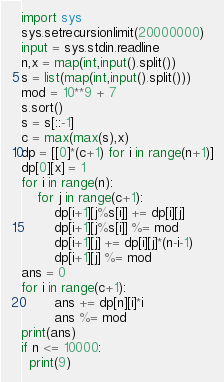Convert code to text. <code><loc_0><loc_0><loc_500><loc_500><_Python_>import sys
sys.setrecursionlimit(20000000)
input = sys.stdin.readline
n,x = map(int,input().split())
s = list(map(int,input().split()))
mod = 10**9 + 7
s.sort()
s = s[::-1]
c = max(max(s),x)
dp = [[0]*(c+1) for i in range(n+1)]
dp[0][x] = 1
for i in range(n):
    for j in range(c+1):
        dp[i+1][j%s[i]] += dp[i][j]
        dp[i+1][j%s[i]] %= mod
        dp[i+1][j] += dp[i][j]*(n-i-1)
        dp[i+1][j] %= mod
ans = 0
for i in range(c+1):
        ans += dp[n][i]*i
        ans %= mod
print(ans)
if n <= 10000:
  print(9)
</code> 